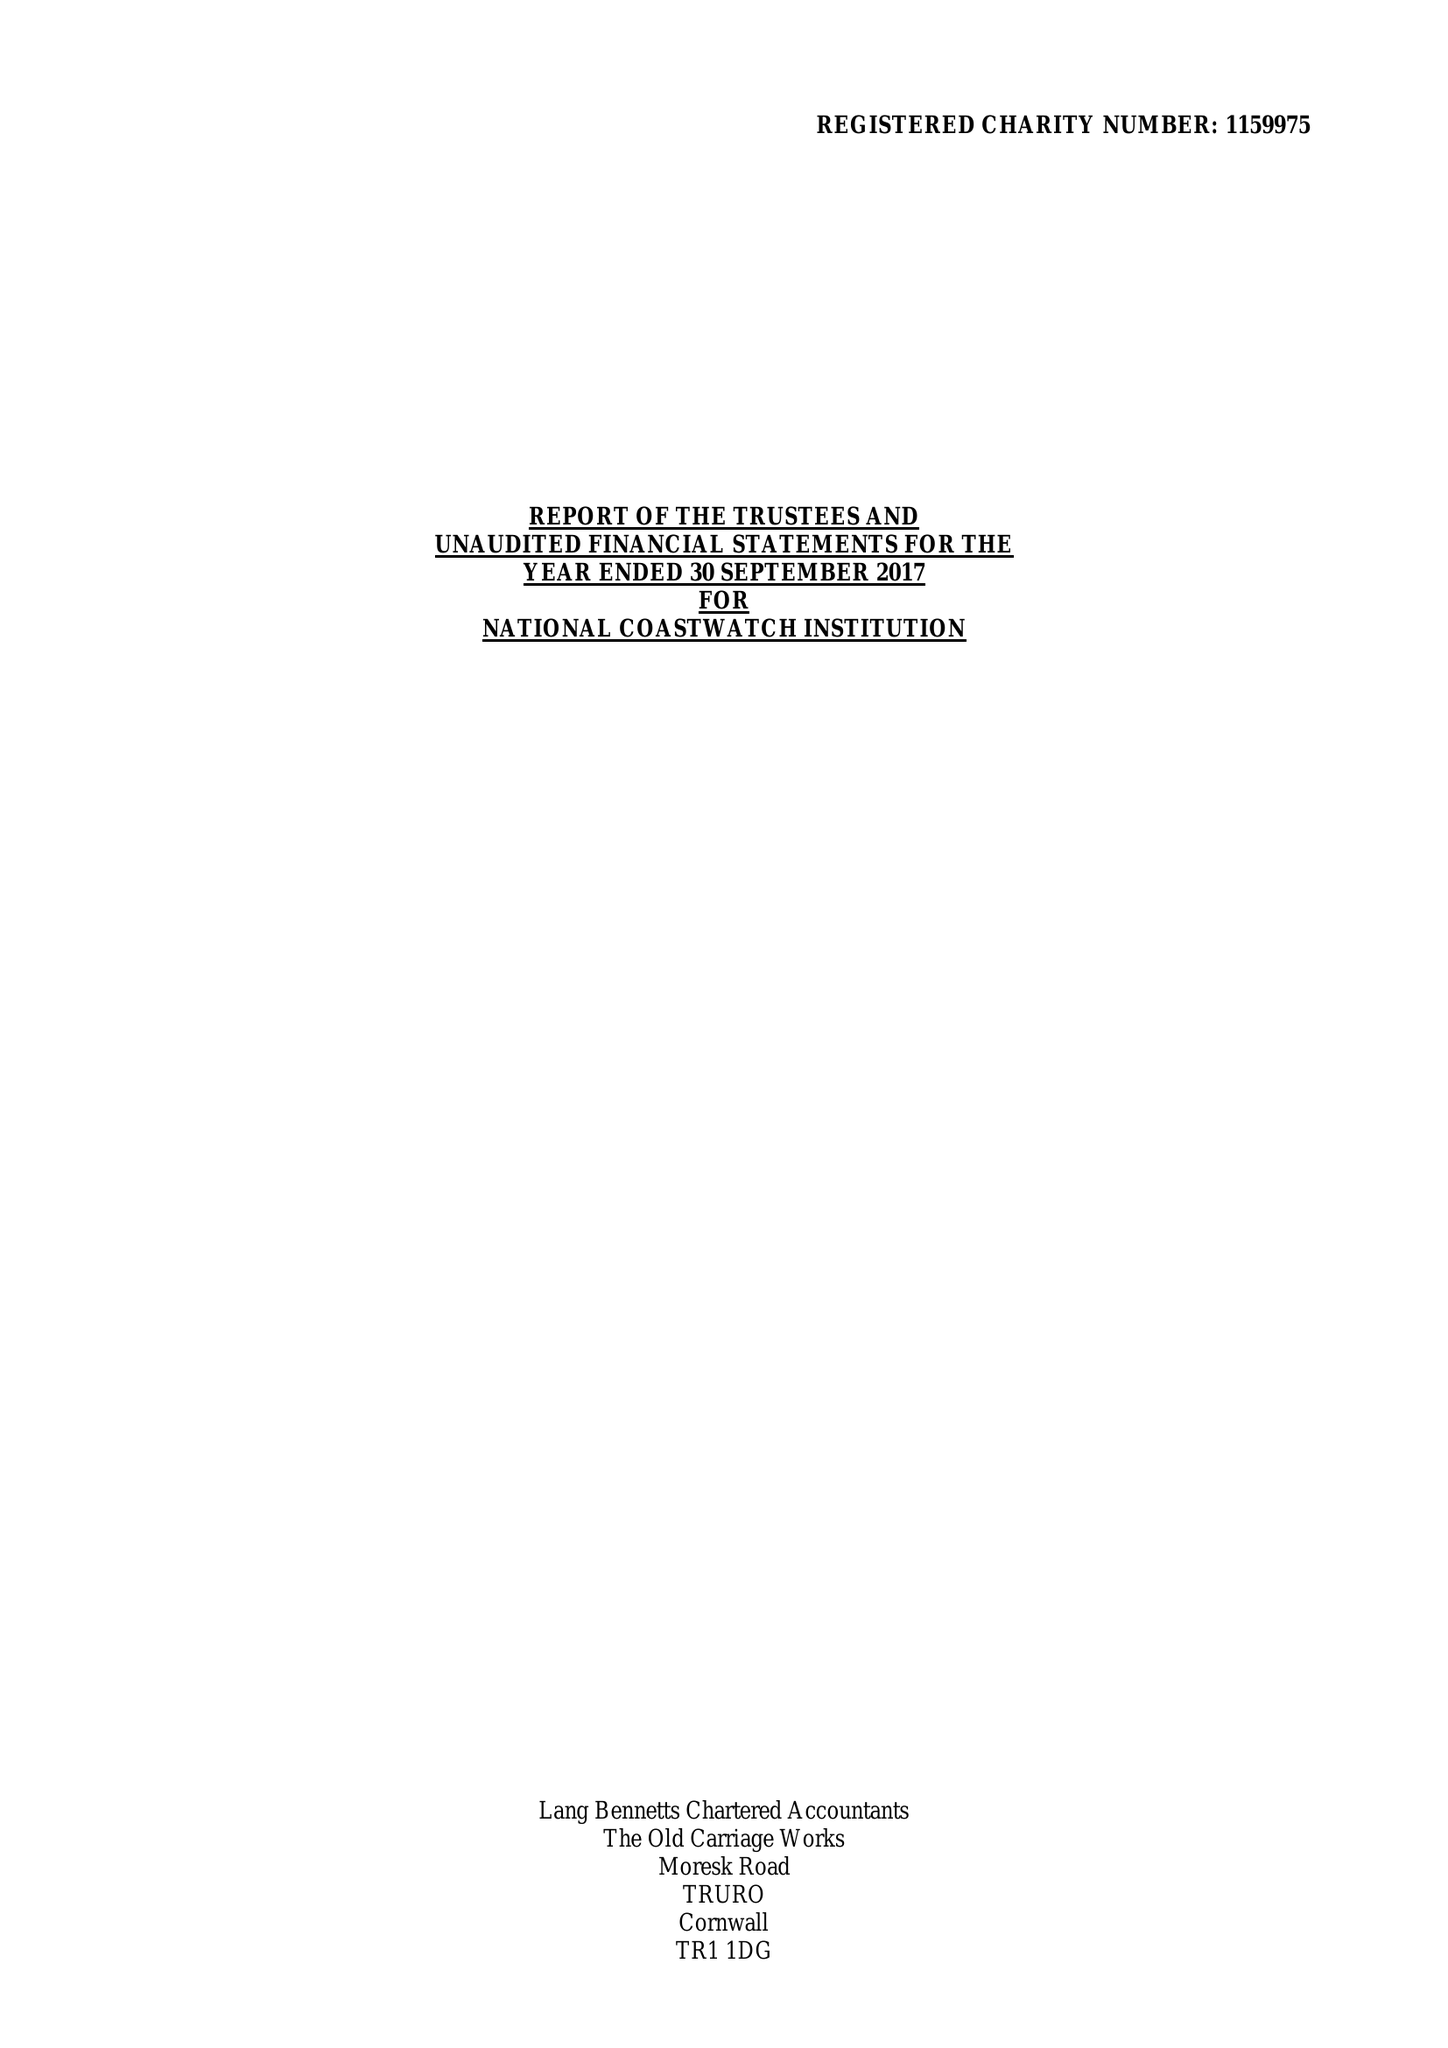What is the value for the spending_annually_in_british_pounds?
Answer the question using a single word or phrase. 452447.00 